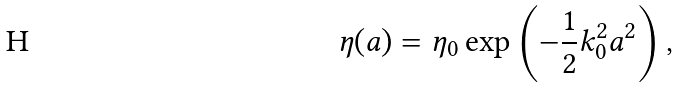Convert formula to latex. <formula><loc_0><loc_0><loc_500><loc_500>\eta ( a ) = \eta _ { 0 } \exp \left ( - \frac { 1 } { 2 } k _ { 0 } ^ { 2 } a ^ { 2 } \right ) ,</formula> 